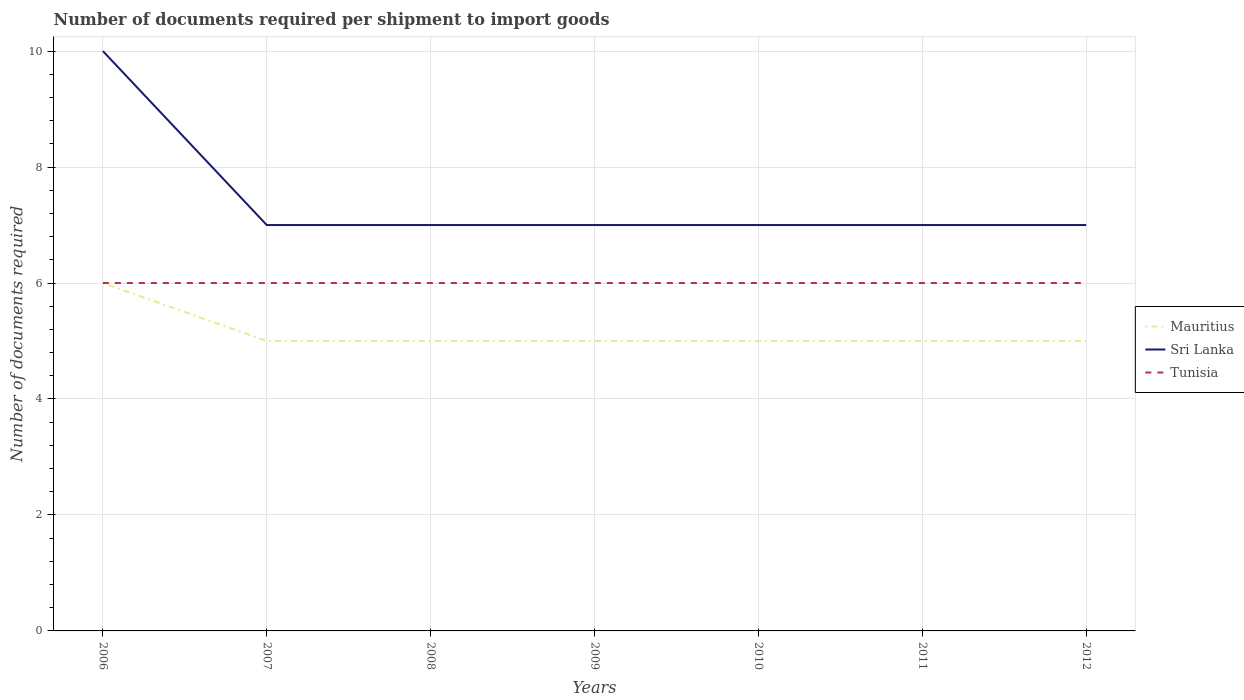How many different coloured lines are there?
Your answer should be compact. 3. Is the number of lines equal to the number of legend labels?
Offer a terse response. Yes. Across all years, what is the maximum number of documents required per shipment to import goods in Tunisia?
Provide a succinct answer. 6. What is the difference between the highest and the lowest number of documents required per shipment to import goods in Tunisia?
Your answer should be very brief. 0. Is the number of documents required per shipment to import goods in Sri Lanka strictly greater than the number of documents required per shipment to import goods in Mauritius over the years?
Provide a short and direct response. No. What is the difference between two consecutive major ticks on the Y-axis?
Ensure brevity in your answer.  2. Are the values on the major ticks of Y-axis written in scientific E-notation?
Offer a terse response. No. Does the graph contain any zero values?
Provide a succinct answer. No. Does the graph contain grids?
Ensure brevity in your answer.  Yes. Where does the legend appear in the graph?
Offer a very short reply. Center right. How many legend labels are there?
Provide a short and direct response. 3. How are the legend labels stacked?
Keep it short and to the point. Vertical. What is the title of the graph?
Offer a terse response. Number of documents required per shipment to import goods. What is the label or title of the Y-axis?
Make the answer very short. Number of documents required. What is the Number of documents required in Mauritius in 2006?
Your response must be concise. 6. What is the Number of documents required in Sri Lanka in 2006?
Give a very brief answer. 10. What is the Number of documents required in Tunisia in 2006?
Provide a succinct answer. 6. What is the Number of documents required of Tunisia in 2007?
Provide a short and direct response. 6. What is the Number of documents required in Sri Lanka in 2008?
Make the answer very short. 7. What is the Number of documents required of Tunisia in 2008?
Provide a succinct answer. 6. What is the Number of documents required in Mauritius in 2009?
Ensure brevity in your answer.  5. What is the Number of documents required of Sri Lanka in 2009?
Offer a very short reply. 7. What is the Number of documents required in Tunisia in 2009?
Give a very brief answer. 6. What is the Number of documents required in Mauritius in 2010?
Give a very brief answer. 5. What is the Number of documents required of Tunisia in 2010?
Ensure brevity in your answer.  6. What is the Number of documents required in Mauritius in 2011?
Provide a short and direct response. 5. What is the Number of documents required of Tunisia in 2011?
Make the answer very short. 6. What is the Number of documents required of Mauritius in 2012?
Provide a short and direct response. 5. Across all years, what is the maximum Number of documents required of Sri Lanka?
Provide a succinct answer. 10. Across all years, what is the maximum Number of documents required in Tunisia?
Make the answer very short. 6. What is the difference between the Number of documents required of Tunisia in 2006 and that in 2007?
Your answer should be very brief. 0. What is the difference between the Number of documents required of Mauritius in 2006 and that in 2009?
Make the answer very short. 1. What is the difference between the Number of documents required in Mauritius in 2006 and that in 2010?
Keep it short and to the point. 1. What is the difference between the Number of documents required in Sri Lanka in 2006 and that in 2010?
Provide a succinct answer. 3. What is the difference between the Number of documents required of Tunisia in 2006 and that in 2010?
Provide a short and direct response. 0. What is the difference between the Number of documents required of Mauritius in 2006 and that in 2012?
Make the answer very short. 1. What is the difference between the Number of documents required in Mauritius in 2007 and that in 2008?
Make the answer very short. 0. What is the difference between the Number of documents required in Sri Lanka in 2007 and that in 2008?
Provide a succinct answer. 0. What is the difference between the Number of documents required of Tunisia in 2007 and that in 2008?
Your answer should be compact. 0. What is the difference between the Number of documents required in Mauritius in 2007 and that in 2009?
Ensure brevity in your answer.  0. What is the difference between the Number of documents required of Tunisia in 2007 and that in 2009?
Offer a very short reply. 0. What is the difference between the Number of documents required in Mauritius in 2007 and that in 2010?
Offer a terse response. 0. What is the difference between the Number of documents required of Sri Lanka in 2007 and that in 2010?
Ensure brevity in your answer.  0. What is the difference between the Number of documents required of Tunisia in 2007 and that in 2011?
Your answer should be compact. 0. What is the difference between the Number of documents required of Sri Lanka in 2007 and that in 2012?
Ensure brevity in your answer.  0. What is the difference between the Number of documents required in Tunisia in 2007 and that in 2012?
Your answer should be very brief. 0. What is the difference between the Number of documents required of Sri Lanka in 2008 and that in 2009?
Offer a terse response. 0. What is the difference between the Number of documents required of Tunisia in 2008 and that in 2010?
Your answer should be compact. 0. What is the difference between the Number of documents required of Tunisia in 2008 and that in 2011?
Give a very brief answer. 0. What is the difference between the Number of documents required in Sri Lanka in 2008 and that in 2012?
Offer a terse response. 0. What is the difference between the Number of documents required of Mauritius in 2009 and that in 2011?
Your response must be concise. 0. What is the difference between the Number of documents required in Sri Lanka in 2009 and that in 2012?
Your answer should be compact. 0. What is the difference between the Number of documents required of Tunisia in 2009 and that in 2012?
Your answer should be very brief. 0. What is the difference between the Number of documents required of Mauritius in 2010 and that in 2011?
Your answer should be very brief. 0. What is the difference between the Number of documents required in Mauritius in 2010 and that in 2012?
Offer a very short reply. 0. What is the difference between the Number of documents required in Sri Lanka in 2010 and that in 2012?
Give a very brief answer. 0. What is the difference between the Number of documents required of Mauritius in 2006 and the Number of documents required of Sri Lanka in 2007?
Your answer should be compact. -1. What is the difference between the Number of documents required of Mauritius in 2006 and the Number of documents required of Tunisia in 2007?
Provide a short and direct response. 0. What is the difference between the Number of documents required of Sri Lanka in 2006 and the Number of documents required of Tunisia in 2007?
Provide a short and direct response. 4. What is the difference between the Number of documents required of Mauritius in 2006 and the Number of documents required of Sri Lanka in 2008?
Your response must be concise. -1. What is the difference between the Number of documents required of Sri Lanka in 2006 and the Number of documents required of Tunisia in 2008?
Your answer should be compact. 4. What is the difference between the Number of documents required in Mauritius in 2006 and the Number of documents required in Tunisia in 2009?
Keep it short and to the point. 0. What is the difference between the Number of documents required in Sri Lanka in 2006 and the Number of documents required in Tunisia in 2009?
Your response must be concise. 4. What is the difference between the Number of documents required in Sri Lanka in 2006 and the Number of documents required in Tunisia in 2010?
Your answer should be compact. 4. What is the difference between the Number of documents required of Mauritius in 2006 and the Number of documents required of Sri Lanka in 2011?
Ensure brevity in your answer.  -1. What is the difference between the Number of documents required in Sri Lanka in 2006 and the Number of documents required in Tunisia in 2011?
Offer a very short reply. 4. What is the difference between the Number of documents required of Mauritius in 2006 and the Number of documents required of Tunisia in 2012?
Give a very brief answer. 0. What is the difference between the Number of documents required in Sri Lanka in 2006 and the Number of documents required in Tunisia in 2012?
Keep it short and to the point. 4. What is the difference between the Number of documents required of Mauritius in 2007 and the Number of documents required of Sri Lanka in 2008?
Your response must be concise. -2. What is the difference between the Number of documents required in Mauritius in 2007 and the Number of documents required in Tunisia in 2008?
Your response must be concise. -1. What is the difference between the Number of documents required in Sri Lanka in 2007 and the Number of documents required in Tunisia in 2008?
Your response must be concise. 1. What is the difference between the Number of documents required of Mauritius in 2007 and the Number of documents required of Sri Lanka in 2009?
Ensure brevity in your answer.  -2. What is the difference between the Number of documents required in Sri Lanka in 2007 and the Number of documents required in Tunisia in 2009?
Ensure brevity in your answer.  1. What is the difference between the Number of documents required of Mauritius in 2007 and the Number of documents required of Sri Lanka in 2010?
Your answer should be very brief. -2. What is the difference between the Number of documents required of Mauritius in 2007 and the Number of documents required of Sri Lanka in 2011?
Your answer should be compact. -2. What is the difference between the Number of documents required of Mauritius in 2007 and the Number of documents required of Tunisia in 2011?
Make the answer very short. -1. What is the difference between the Number of documents required of Sri Lanka in 2007 and the Number of documents required of Tunisia in 2011?
Keep it short and to the point. 1. What is the difference between the Number of documents required of Mauritius in 2007 and the Number of documents required of Sri Lanka in 2012?
Keep it short and to the point. -2. What is the difference between the Number of documents required in Mauritius in 2008 and the Number of documents required in Tunisia in 2010?
Offer a very short reply. -1. What is the difference between the Number of documents required of Sri Lanka in 2008 and the Number of documents required of Tunisia in 2010?
Offer a terse response. 1. What is the difference between the Number of documents required in Mauritius in 2008 and the Number of documents required in Sri Lanka in 2012?
Your answer should be very brief. -2. What is the difference between the Number of documents required in Sri Lanka in 2009 and the Number of documents required in Tunisia in 2010?
Your response must be concise. 1. What is the difference between the Number of documents required of Mauritius in 2009 and the Number of documents required of Sri Lanka in 2011?
Provide a succinct answer. -2. What is the difference between the Number of documents required of Sri Lanka in 2009 and the Number of documents required of Tunisia in 2011?
Provide a short and direct response. 1. What is the difference between the Number of documents required in Mauritius in 2009 and the Number of documents required in Tunisia in 2012?
Your answer should be very brief. -1. What is the difference between the Number of documents required in Mauritius in 2010 and the Number of documents required in Sri Lanka in 2012?
Keep it short and to the point. -2. What is the difference between the Number of documents required of Mauritius in 2011 and the Number of documents required of Tunisia in 2012?
Provide a short and direct response. -1. What is the difference between the Number of documents required of Sri Lanka in 2011 and the Number of documents required of Tunisia in 2012?
Keep it short and to the point. 1. What is the average Number of documents required in Mauritius per year?
Your answer should be very brief. 5.14. What is the average Number of documents required in Sri Lanka per year?
Your answer should be compact. 7.43. What is the average Number of documents required of Tunisia per year?
Offer a terse response. 6. In the year 2007, what is the difference between the Number of documents required of Mauritius and Number of documents required of Sri Lanka?
Offer a very short reply. -2. In the year 2007, what is the difference between the Number of documents required of Mauritius and Number of documents required of Tunisia?
Your answer should be very brief. -1. In the year 2008, what is the difference between the Number of documents required in Mauritius and Number of documents required in Sri Lanka?
Ensure brevity in your answer.  -2. In the year 2008, what is the difference between the Number of documents required in Mauritius and Number of documents required in Tunisia?
Keep it short and to the point. -1. In the year 2008, what is the difference between the Number of documents required in Sri Lanka and Number of documents required in Tunisia?
Offer a terse response. 1. In the year 2009, what is the difference between the Number of documents required in Sri Lanka and Number of documents required in Tunisia?
Give a very brief answer. 1. In the year 2010, what is the difference between the Number of documents required of Mauritius and Number of documents required of Sri Lanka?
Ensure brevity in your answer.  -2. In the year 2010, what is the difference between the Number of documents required in Mauritius and Number of documents required in Tunisia?
Ensure brevity in your answer.  -1. In the year 2011, what is the difference between the Number of documents required of Sri Lanka and Number of documents required of Tunisia?
Provide a short and direct response. 1. In the year 2012, what is the difference between the Number of documents required in Mauritius and Number of documents required in Sri Lanka?
Provide a short and direct response. -2. In the year 2012, what is the difference between the Number of documents required of Mauritius and Number of documents required of Tunisia?
Make the answer very short. -1. In the year 2012, what is the difference between the Number of documents required in Sri Lanka and Number of documents required in Tunisia?
Make the answer very short. 1. What is the ratio of the Number of documents required of Mauritius in 2006 to that in 2007?
Keep it short and to the point. 1.2. What is the ratio of the Number of documents required of Sri Lanka in 2006 to that in 2007?
Give a very brief answer. 1.43. What is the ratio of the Number of documents required in Tunisia in 2006 to that in 2007?
Your answer should be compact. 1. What is the ratio of the Number of documents required of Mauritius in 2006 to that in 2008?
Offer a terse response. 1.2. What is the ratio of the Number of documents required in Sri Lanka in 2006 to that in 2008?
Offer a very short reply. 1.43. What is the ratio of the Number of documents required of Tunisia in 2006 to that in 2008?
Make the answer very short. 1. What is the ratio of the Number of documents required of Sri Lanka in 2006 to that in 2009?
Provide a succinct answer. 1.43. What is the ratio of the Number of documents required in Mauritius in 2006 to that in 2010?
Give a very brief answer. 1.2. What is the ratio of the Number of documents required in Sri Lanka in 2006 to that in 2010?
Offer a very short reply. 1.43. What is the ratio of the Number of documents required of Mauritius in 2006 to that in 2011?
Your response must be concise. 1.2. What is the ratio of the Number of documents required in Sri Lanka in 2006 to that in 2011?
Provide a succinct answer. 1.43. What is the ratio of the Number of documents required of Mauritius in 2006 to that in 2012?
Provide a short and direct response. 1.2. What is the ratio of the Number of documents required of Sri Lanka in 2006 to that in 2012?
Your answer should be very brief. 1.43. What is the ratio of the Number of documents required in Sri Lanka in 2007 to that in 2008?
Provide a succinct answer. 1. What is the ratio of the Number of documents required in Mauritius in 2007 to that in 2009?
Your answer should be compact. 1. What is the ratio of the Number of documents required of Tunisia in 2007 to that in 2009?
Offer a terse response. 1. What is the ratio of the Number of documents required in Mauritius in 2007 to that in 2010?
Your answer should be very brief. 1. What is the ratio of the Number of documents required in Sri Lanka in 2007 to that in 2010?
Your response must be concise. 1. What is the ratio of the Number of documents required in Sri Lanka in 2007 to that in 2011?
Your answer should be very brief. 1. What is the ratio of the Number of documents required of Tunisia in 2007 to that in 2011?
Give a very brief answer. 1. What is the ratio of the Number of documents required of Mauritius in 2007 to that in 2012?
Ensure brevity in your answer.  1. What is the ratio of the Number of documents required of Sri Lanka in 2007 to that in 2012?
Your answer should be compact. 1. What is the ratio of the Number of documents required of Tunisia in 2007 to that in 2012?
Keep it short and to the point. 1. What is the ratio of the Number of documents required of Mauritius in 2008 to that in 2009?
Give a very brief answer. 1. What is the ratio of the Number of documents required of Sri Lanka in 2008 to that in 2009?
Provide a short and direct response. 1. What is the ratio of the Number of documents required of Tunisia in 2008 to that in 2010?
Your answer should be very brief. 1. What is the ratio of the Number of documents required in Sri Lanka in 2008 to that in 2012?
Keep it short and to the point. 1. What is the ratio of the Number of documents required in Mauritius in 2009 to that in 2010?
Keep it short and to the point. 1. What is the ratio of the Number of documents required in Tunisia in 2009 to that in 2010?
Keep it short and to the point. 1. What is the ratio of the Number of documents required of Mauritius in 2009 to that in 2011?
Give a very brief answer. 1. What is the ratio of the Number of documents required of Tunisia in 2009 to that in 2011?
Provide a succinct answer. 1. What is the ratio of the Number of documents required of Sri Lanka in 2009 to that in 2012?
Give a very brief answer. 1. What is the ratio of the Number of documents required of Tunisia in 2009 to that in 2012?
Keep it short and to the point. 1. What is the ratio of the Number of documents required of Tunisia in 2010 to that in 2011?
Give a very brief answer. 1. What is the ratio of the Number of documents required of Mauritius in 2010 to that in 2012?
Provide a short and direct response. 1. What is the ratio of the Number of documents required of Sri Lanka in 2010 to that in 2012?
Your answer should be compact. 1. What is the ratio of the Number of documents required of Mauritius in 2011 to that in 2012?
Offer a terse response. 1. What is the ratio of the Number of documents required in Sri Lanka in 2011 to that in 2012?
Your answer should be very brief. 1. What is the ratio of the Number of documents required in Tunisia in 2011 to that in 2012?
Your answer should be compact. 1. What is the difference between the highest and the second highest Number of documents required of Tunisia?
Your answer should be very brief. 0. What is the difference between the highest and the lowest Number of documents required in Sri Lanka?
Give a very brief answer. 3. 